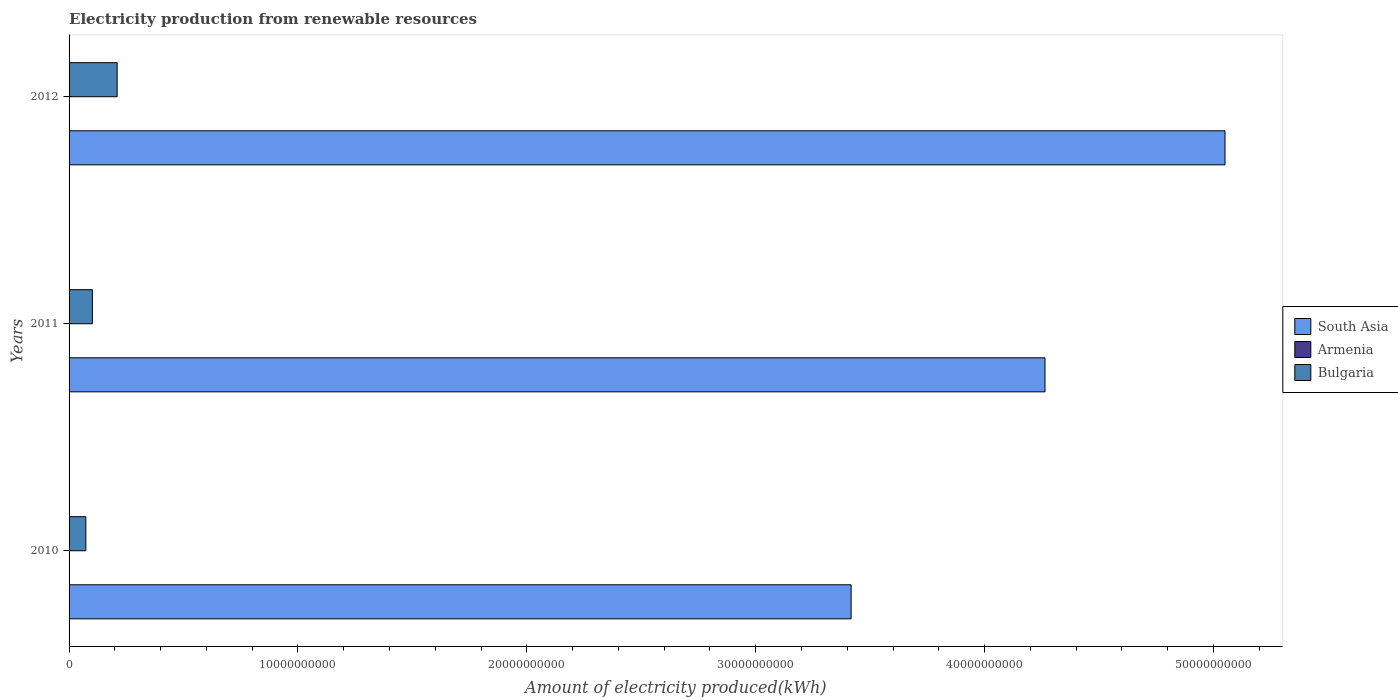How many bars are there on the 3rd tick from the top?
Your answer should be very brief. 3. How many bars are there on the 1st tick from the bottom?
Keep it short and to the point. 3. What is the amount of electricity produced in South Asia in 2012?
Offer a terse response. 5.05e+1. Across all years, what is the maximum amount of electricity produced in South Asia?
Offer a very short reply. 5.05e+1. In which year was the amount of electricity produced in South Asia minimum?
Your answer should be very brief. 2010. What is the total amount of electricity produced in Armenia in the graph?
Keep it short and to the point. 1.70e+07. What is the difference between the amount of electricity produced in Bulgaria in 2010 and that in 2012?
Offer a terse response. -1.37e+09. What is the difference between the amount of electricity produced in Bulgaria in 2011 and the amount of electricity produced in Armenia in 2012?
Offer a very short reply. 1.01e+09. What is the average amount of electricity produced in Armenia per year?
Offer a very short reply. 5.67e+06. In the year 2012, what is the difference between the amount of electricity produced in Armenia and amount of electricity produced in South Asia?
Your answer should be very brief. -5.05e+1. What is the difference between the highest and the lowest amount of electricity produced in Bulgaria?
Your answer should be very brief. 1.37e+09. What does the 3rd bar from the top in 2011 represents?
Offer a very short reply. South Asia. What does the 2nd bar from the bottom in 2010 represents?
Keep it short and to the point. Armenia. Is it the case that in every year, the sum of the amount of electricity produced in Armenia and amount of electricity produced in Bulgaria is greater than the amount of electricity produced in South Asia?
Your response must be concise. No. Are all the bars in the graph horizontal?
Your answer should be compact. Yes. What is the difference between two consecutive major ticks on the X-axis?
Your answer should be very brief. 1.00e+1. Are the values on the major ticks of X-axis written in scientific E-notation?
Ensure brevity in your answer.  No. Does the graph contain grids?
Ensure brevity in your answer.  No. How many legend labels are there?
Make the answer very short. 3. How are the legend labels stacked?
Offer a terse response. Vertical. What is the title of the graph?
Provide a succinct answer. Electricity production from renewable resources. Does "Guinea-Bissau" appear as one of the legend labels in the graph?
Provide a succinct answer. No. What is the label or title of the X-axis?
Your response must be concise. Amount of electricity produced(kWh). What is the Amount of electricity produced(kWh) of South Asia in 2010?
Keep it short and to the point. 3.42e+1. What is the Amount of electricity produced(kWh) of Armenia in 2010?
Offer a very short reply. 7.00e+06. What is the Amount of electricity produced(kWh) in Bulgaria in 2010?
Your answer should be very brief. 7.32e+08. What is the Amount of electricity produced(kWh) of South Asia in 2011?
Give a very brief answer. 4.26e+1. What is the Amount of electricity produced(kWh) in Bulgaria in 2011?
Your response must be concise. 1.02e+09. What is the Amount of electricity produced(kWh) of South Asia in 2012?
Give a very brief answer. 5.05e+1. What is the Amount of electricity produced(kWh) in Bulgaria in 2012?
Ensure brevity in your answer.  2.10e+09. Across all years, what is the maximum Amount of electricity produced(kWh) of South Asia?
Provide a succinct answer. 5.05e+1. Across all years, what is the maximum Amount of electricity produced(kWh) of Armenia?
Your answer should be very brief. 7.00e+06. Across all years, what is the maximum Amount of electricity produced(kWh) in Bulgaria?
Offer a terse response. 2.10e+09. Across all years, what is the minimum Amount of electricity produced(kWh) in South Asia?
Ensure brevity in your answer.  3.42e+1. Across all years, what is the minimum Amount of electricity produced(kWh) in Armenia?
Your response must be concise. 4.00e+06. Across all years, what is the minimum Amount of electricity produced(kWh) of Bulgaria?
Your response must be concise. 7.32e+08. What is the total Amount of electricity produced(kWh) of South Asia in the graph?
Keep it short and to the point. 1.27e+11. What is the total Amount of electricity produced(kWh) in Armenia in the graph?
Your response must be concise. 1.70e+07. What is the total Amount of electricity produced(kWh) in Bulgaria in the graph?
Offer a terse response. 3.85e+09. What is the difference between the Amount of electricity produced(kWh) of South Asia in 2010 and that in 2011?
Offer a terse response. -8.47e+09. What is the difference between the Amount of electricity produced(kWh) in Bulgaria in 2010 and that in 2011?
Ensure brevity in your answer.  -2.86e+08. What is the difference between the Amount of electricity produced(kWh) in South Asia in 2010 and that in 2012?
Provide a succinct answer. -1.63e+1. What is the difference between the Amount of electricity produced(kWh) in Bulgaria in 2010 and that in 2012?
Provide a succinct answer. -1.37e+09. What is the difference between the Amount of electricity produced(kWh) in South Asia in 2011 and that in 2012?
Your response must be concise. -7.86e+09. What is the difference between the Amount of electricity produced(kWh) in Bulgaria in 2011 and that in 2012?
Your answer should be compact. -1.08e+09. What is the difference between the Amount of electricity produced(kWh) in South Asia in 2010 and the Amount of electricity produced(kWh) in Armenia in 2011?
Offer a terse response. 3.42e+1. What is the difference between the Amount of electricity produced(kWh) of South Asia in 2010 and the Amount of electricity produced(kWh) of Bulgaria in 2011?
Your answer should be compact. 3.32e+1. What is the difference between the Amount of electricity produced(kWh) in Armenia in 2010 and the Amount of electricity produced(kWh) in Bulgaria in 2011?
Your response must be concise. -1.01e+09. What is the difference between the Amount of electricity produced(kWh) in South Asia in 2010 and the Amount of electricity produced(kWh) in Armenia in 2012?
Keep it short and to the point. 3.42e+1. What is the difference between the Amount of electricity produced(kWh) in South Asia in 2010 and the Amount of electricity produced(kWh) in Bulgaria in 2012?
Keep it short and to the point. 3.21e+1. What is the difference between the Amount of electricity produced(kWh) of Armenia in 2010 and the Amount of electricity produced(kWh) of Bulgaria in 2012?
Provide a short and direct response. -2.09e+09. What is the difference between the Amount of electricity produced(kWh) in South Asia in 2011 and the Amount of electricity produced(kWh) in Armenia in 2012?
Offer a very short reply. 4.26e+1. What is the difference between the Amount of electricity produced(kWh) in South Asia in 2011 and the Amount of electricity produced(kWh) in Bulgaria in 2012?
Provide a succinct answer. 4.05e+1. What is the difference between the Amount of electricity produced(kWh) of Armenia in 2011 and the Amount of electricity produced(kWh) of Bulgaria in 2012?
Make the answer very short. -2.10e+09. What is the average Amount of electricity produced(kWh) in South Asia per year?
Offer a very short reply. 4.24e+1. What is the average Amount of electricity produced(kWh) of Armenia per year?
Make the answer very short. 5.67e+06. What is the average Amount of electricity produced(kWh) in Bulgaria per year?
Offer a terse response. 1.28e+09. In the year 2010, what is the difference between the Amount of electricity produced(kWh) in South Asia and Amount of electricity produced(kWh) in Armenia?
Provide a short and direct response. 3.42e+1. In the year 2010, what is the difference between the Amount of electricity produced(kWh) in South Asia and Amount of electricity produced(kWh) in Bulgaria?
Keep it short and to the point. 3.34e+1. In the year 2010, what is the difference between the Amount of electricity produced(kWh) in Armenia and Amount of electricity produced(kWh) in Bulgaria?
Provide a short and direct response. -7.25e+08. In the year 2011, what is the difference between the Amount of electricity produced(kWh) of South Asia and Amount of electricity produced(kWh) of Armenia?
Provide a succinct answer. 4.26e+1. In the year 2011, what is the difference between the Amount of electricity produced(kWh) in South Asia and Amount of electricity produced(kWh) in Bulgaria?
Keep it short and to the point. 4.16e+1. In the year 2011, what is the difference between the Amount of electricity produced(kWh) of Armenia and Amount of electricity produced(kWh) of Bulgaria?
Offer a terse response. -1.01e+09. In the year 2012, what is the difference between the Amount of electricity produced(kWh) in South Asia and Amount of electricity produced(kWh) in Armenia?
Offer a very short reply. 5.05e+1. In the year 2012, what is the difference between the Amount of electricity produced(kWh) in South Asia and Amount of electricity produced(kWh) in Bulgaria?
Give a very brief answer. 4.84e+1. In the year 2012, what is the difference between the Amount of electricity produced(kWh) of Armenia and Amount of electricity produced(kWh) of Bulgaria?
Give a very brief answer. -2.10e+09. What is the ratio of the Amount of electricity produced(kWh) of South Asia in 2010 to that in 2011?
Make the answer very short. 0.8. What is the ratio of the Amount of electricity produced(kWh) of Bulgaria in 2010 to that in 2011?
Offer a terse response. 0.72. What is the ratio of the Amount of electricity produced(kWh) of South Asia in 2010 to that in 2012?
Make the answer very short. 0.68. What is the ratio of the Amount of electricity produced(kWh) of Armenia in 2010 to that in 2012?
Keep it short and to the point. 1.75. What is the ratio of the Amount of electricity produced(kWh) in Bulgaria in 2010 to that in 2012?
Your answer should be very brief. 0.35. What is the ratio of the Amount of electricity produced(kWh) of South Asia in 2011 to that in 2012?
Offer a very short reply. 0.84. What is the ratio of the Amount of electricity produced(kWh) in Armenia in 2011 to that in 2012?
Your response must be concise. 1.5. What is the ratio of the Amount of electricity produced(kWh) of Bulgaria in 2011 to that in 2012?
Provide a short and direct response. 0.48. What is the difference between the highest and the second highest Amount of electricity produced(kWh) of South Asia?
Your answer should be very brief. 7.86e+09. What is the difference between the highest and the second highest Amount of electricity produced(kWh) of Bulgaria?
Your response must be concise. 1.08e+09. What is the difference between the highest and the lowest Amount of electricity produced(kWh) of South Asia?
Your answer should be very brief. 1.63e+1. What is the difference between the highest and the lowest Amount of electricity produced(kWh) in Armenia?
Give a very brief answer. 3.00e+06. What is the difference between the highest and the lowest Amount of electricity produced(kWh) in Bulgaria?
Give a very brief answer. 1.37e+09. 